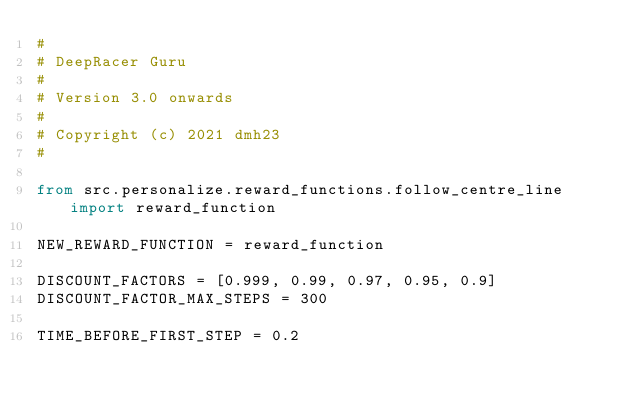<code> <loc_0><loc_0><loc_500><loc_500><_Python_>#
# DeepRacer Guru
#
# Version 3.0 onwards
#
# Copyright (c) 2021 dmh23
#

from src.personalize.reward_functions.follow_centre_line import reward_function

NEW_REWARD_FUNCTION = reward_function

DISCOUNT_FACTORS = [0.999, 0.99, 0.97, 0.95, 0.9]
DISCOUNT_FACTOR_MAX_STEPS = 300

TIME_BEFORE_FIRST_STEP = 0.2
</code> 